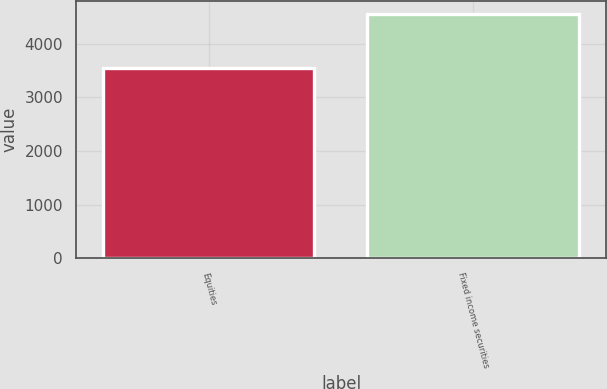Convert chart to OTSL. <chart><loc_0><loc_0><loc_500><loc_500><bar_chart><fcel>Equities<fcel>Fixed income securities<nl><fcel>3555<fcel>4565<nl></chart> 